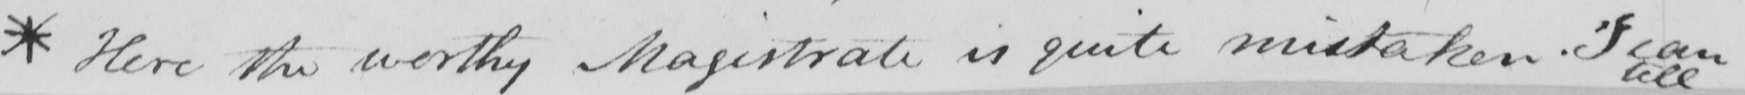Please provide the text content of this handwritten line. * Here the worthy Magistrate is quite mistaken .  " I can 